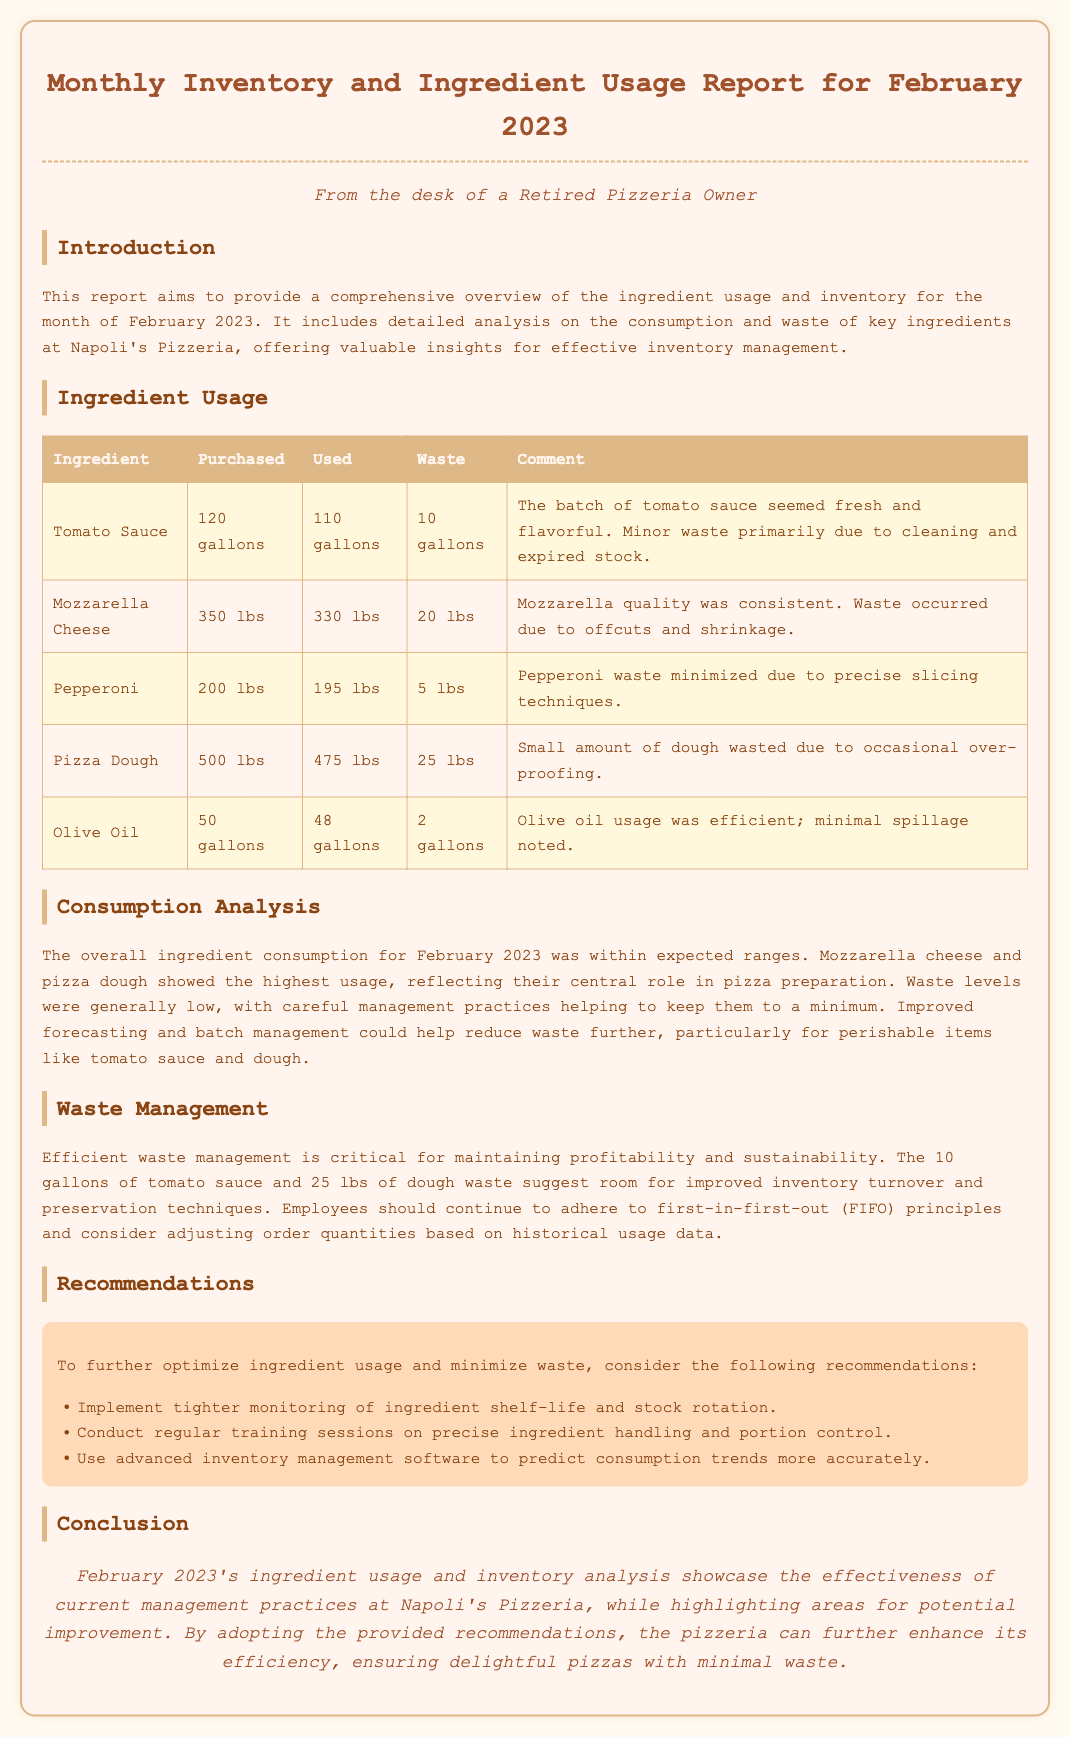What was the total amount of tomato sauce purchased? The purchased amount of tomato sauce is stated in the ingredient usage table, which shows 120 gallons.
Answer: 120 gallons How much mozzarella cheese was wasted? The waste for mozzarella cheese is provided in the ingredient usage table, which indicates 20 lbs.
Answer: 20 lbs What was the waste for pizza dough? The waste for pizza dough is detailed in the ingredient usage table, showing that 25 lbs were wasted.
Answer: 25 lbs Which ingredient had the least amount of waste? By comparing the waste figures in the ingredient usage table, pepperoni had the least waste at 5 lbs.
Answer: 5 lbs What recommendations are made for ingredient usage? The recommendations section highlights three specific suggestions for improving ingredient usage efficiency.
Answer: Tighter monitoring of ingredient shelf-life and stock rotation How many gallons of olive oil were used? The used amount of olive oil is found in the ingredient usage table, which lists 48 gallons used.
Answer: 48 gallons What is the overall conclusion regarding the management practices? The overall conclusion summarizes the effectiveness of current management practices, captured in the concluding paragraph.
Answer: Effectiveness of current management practices How much pepperoni was purchased? The purchased amount of pepperoni is included in the ingredient usage table, which shows 200 lbs.
Answer: 200 lbs What does "FIFO" stand for? The term "FIFO" mentioned in the waste management section refers to a common inventory management method.
Answer: First-in-first-out 